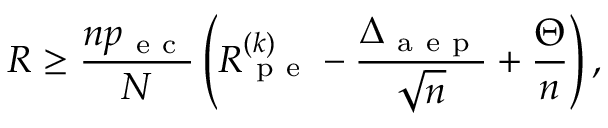<formula> <loc_0><loc_0><loc_500><loc_500>R \geq \frac { n p _ { e c } } { N } \left ( R _ { p e } ^ { ( k ) } - \frac { \Delta _ { a e p } } { \sqrt { n } } + \frac { \Theta } { n } \right ) ,</formula> 